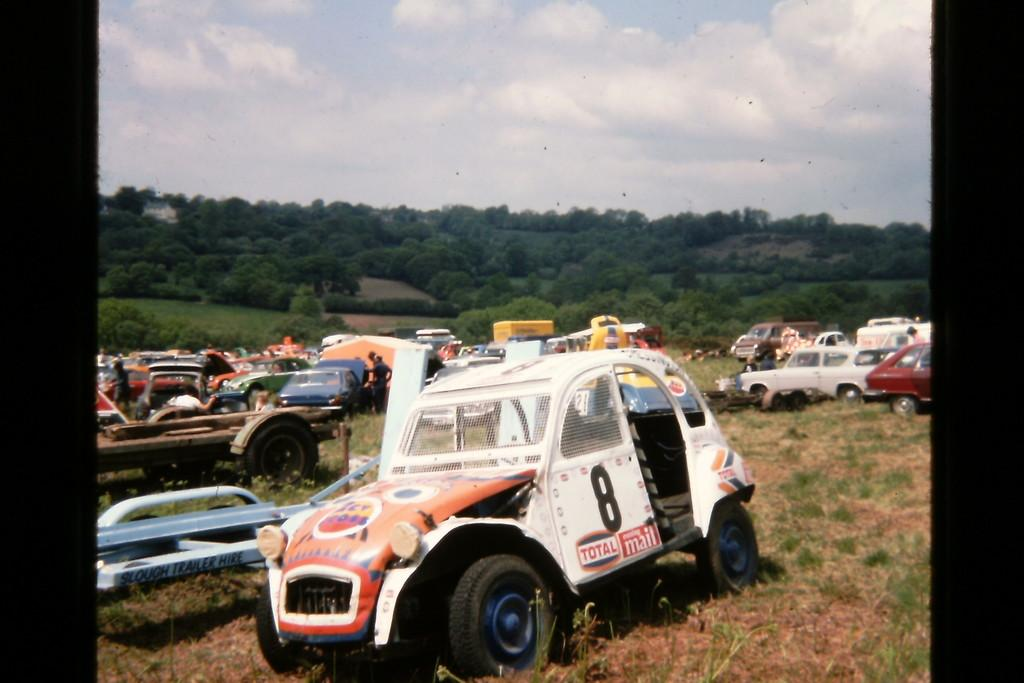What type of surface can be seen in the image? Ground is visible in the image. What else can be seen moving in the image? There are vehicles in the image. What type of vegetation is present in the image? Grass is present in the image. Are there any living beings in the image? Yes, there are people in the image. What else can be seen in the background of the image? Trees are visible in the image. What is visible above the trees and vehicles in the image? The sky is visible in the background of the image, and clouds are present in the sky. How many seats are available for the trees in the image? There are no seats present in the image, and trees do not require seats. 